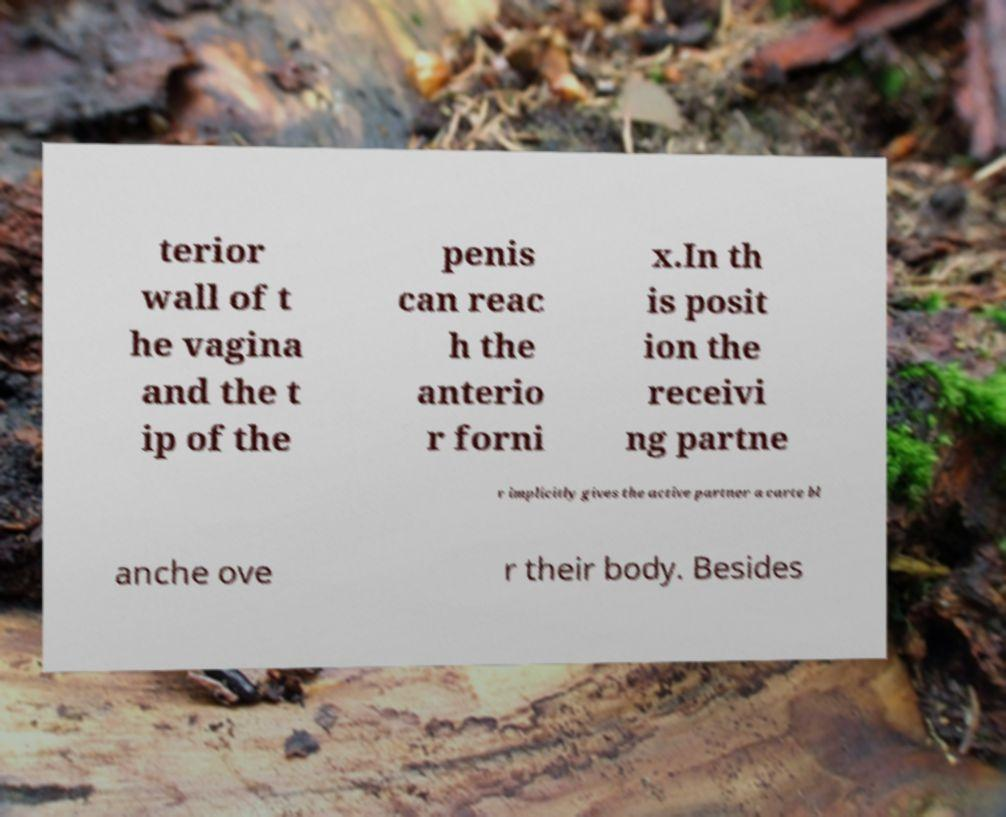Could you extract and type out the text from this image? terior wall of t he vagina and the t ip of the penis can reac h the anterio r forni x.In th is posit ion the receivi ng partne r implicitly gives the active partner a carte bl anche ove r their body. Besides 